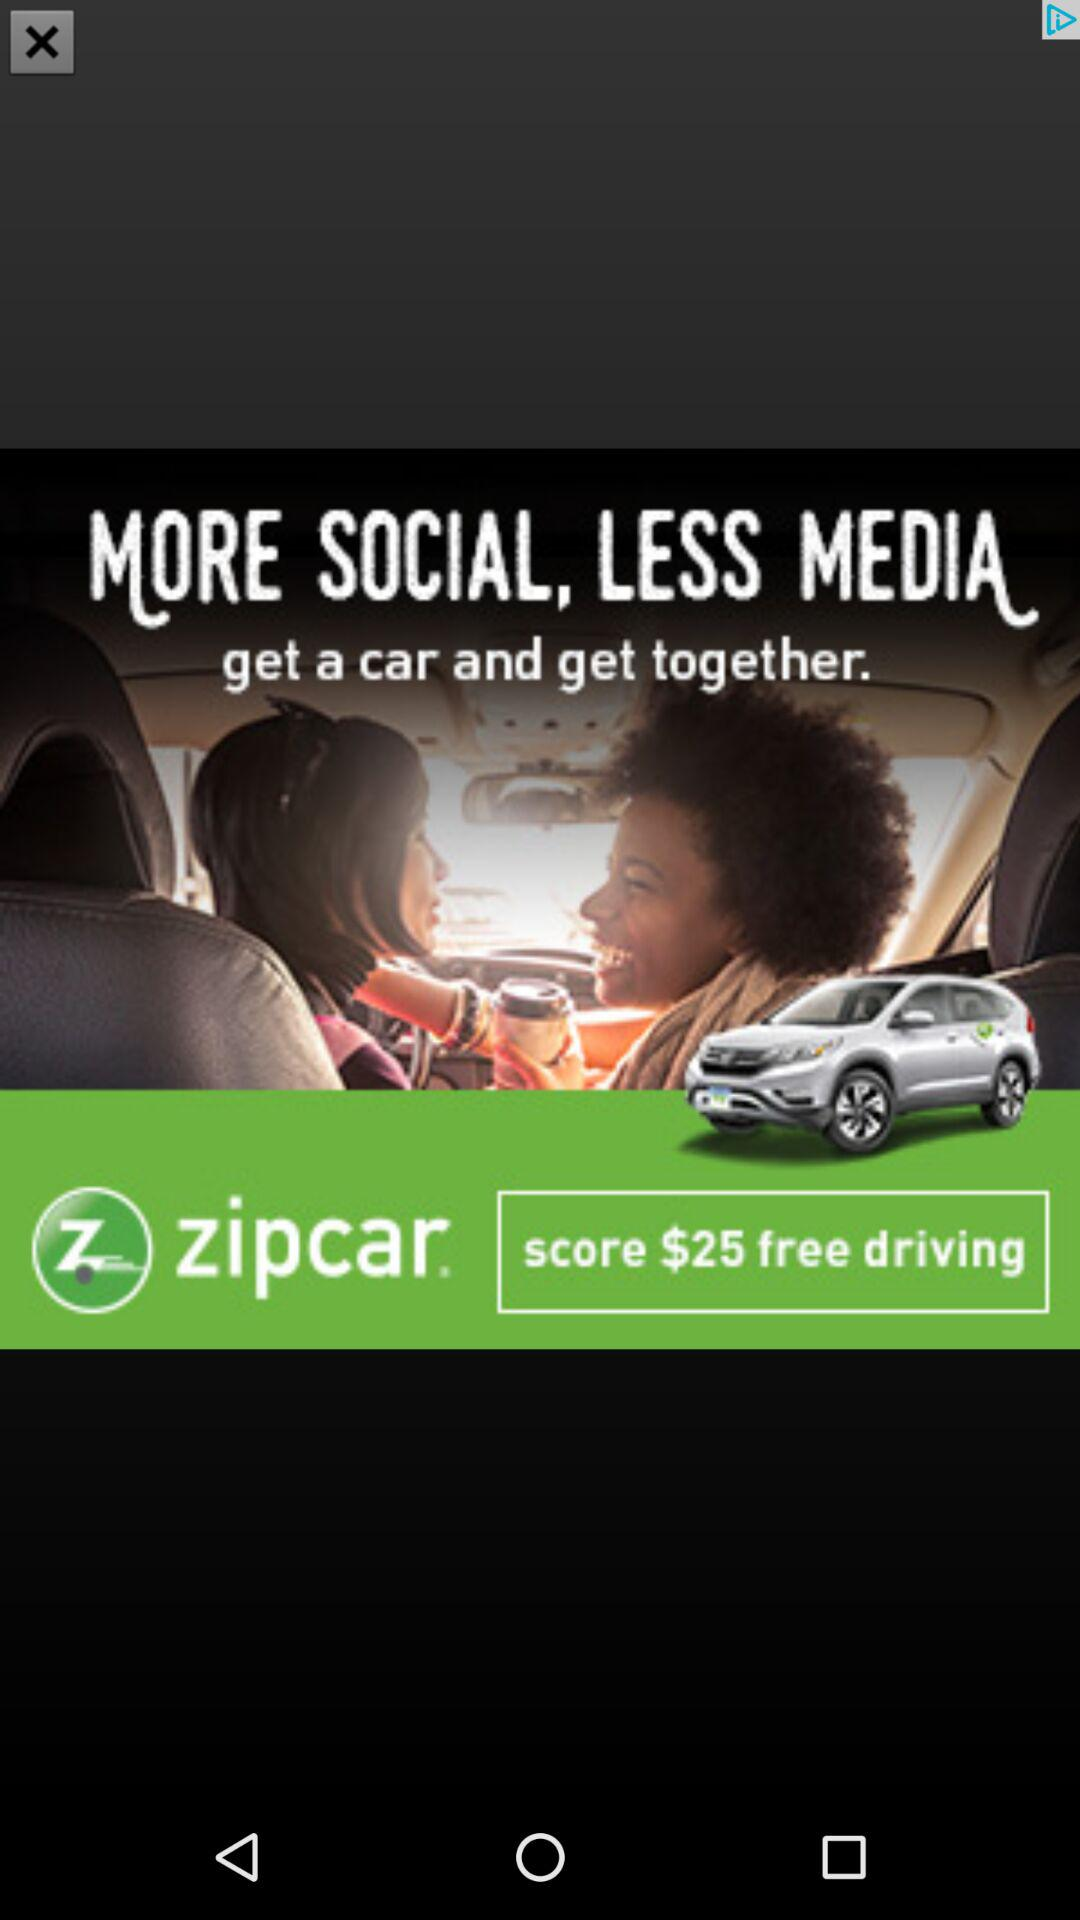How much money is the user eligible to earn for free driving?
Answer the question using a single word or phrase. $25 